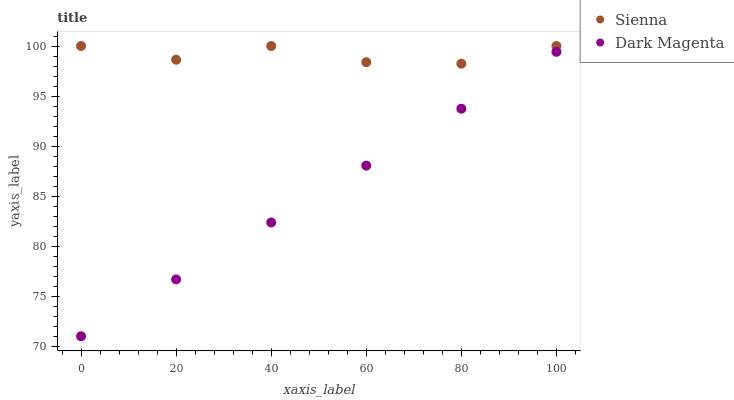Does Dark Magenta have the minimum area under the curve?
Answer yes or no. Yes. Does Sienna have the maximum area under the curve?
Answer yes or no. Yes. Does Dark Magenta have the maximum area under the curve?
Answer yes or no. No. Is Dark Magenta the smoothest?
Answer yes or no. Yes. Is Sienna the roughest?
Answer yes or no. Yes. Is Dark Magenta the roughest?
Answer yes or no. No. Does Dark Magenta have the lowest value?
Answer yes or no. Yes. Does Sienna have the highest value?
Answer yes or no. Yes. Does Dark Magenta have the highest value?
Answer yes or no. No. Is Dark Magenta less than Sienna?
Answer yes or no. Yes. Is Sienna greater than Dark Magenta?
Answer yes or no. Yes. Does Dark Magenta intersect Sienna?
Answer yes or no. No. 